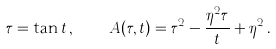Convert formula to latex. <formula><loc_0><loc_0><loc_500><loc_500>\tau = \tan t \, , \quad A ( \tau , t ) = \tau ^ { 2 } - \frac { \eta ^ { 2 } \tau } t + \eta ^ { 2 } \, .</formula> 